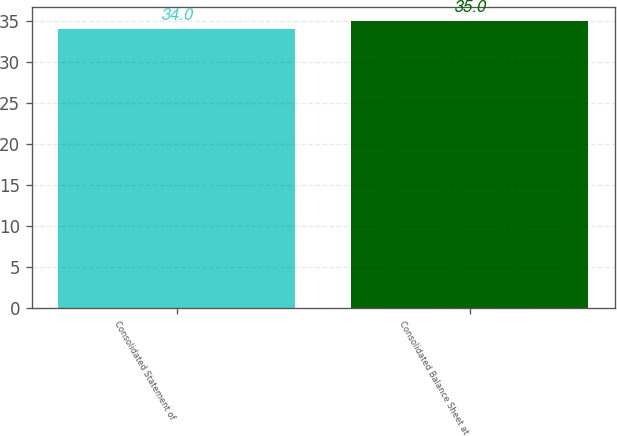Convert chart to OTSL. <chart><loc_0><loc_0><loc_500><loc_500><bar_chart><fcel>Consolidated Statement of<fcel>Consolidated Balance Sheet at<nl><fcel>34<fcel>35<nl></chart> 